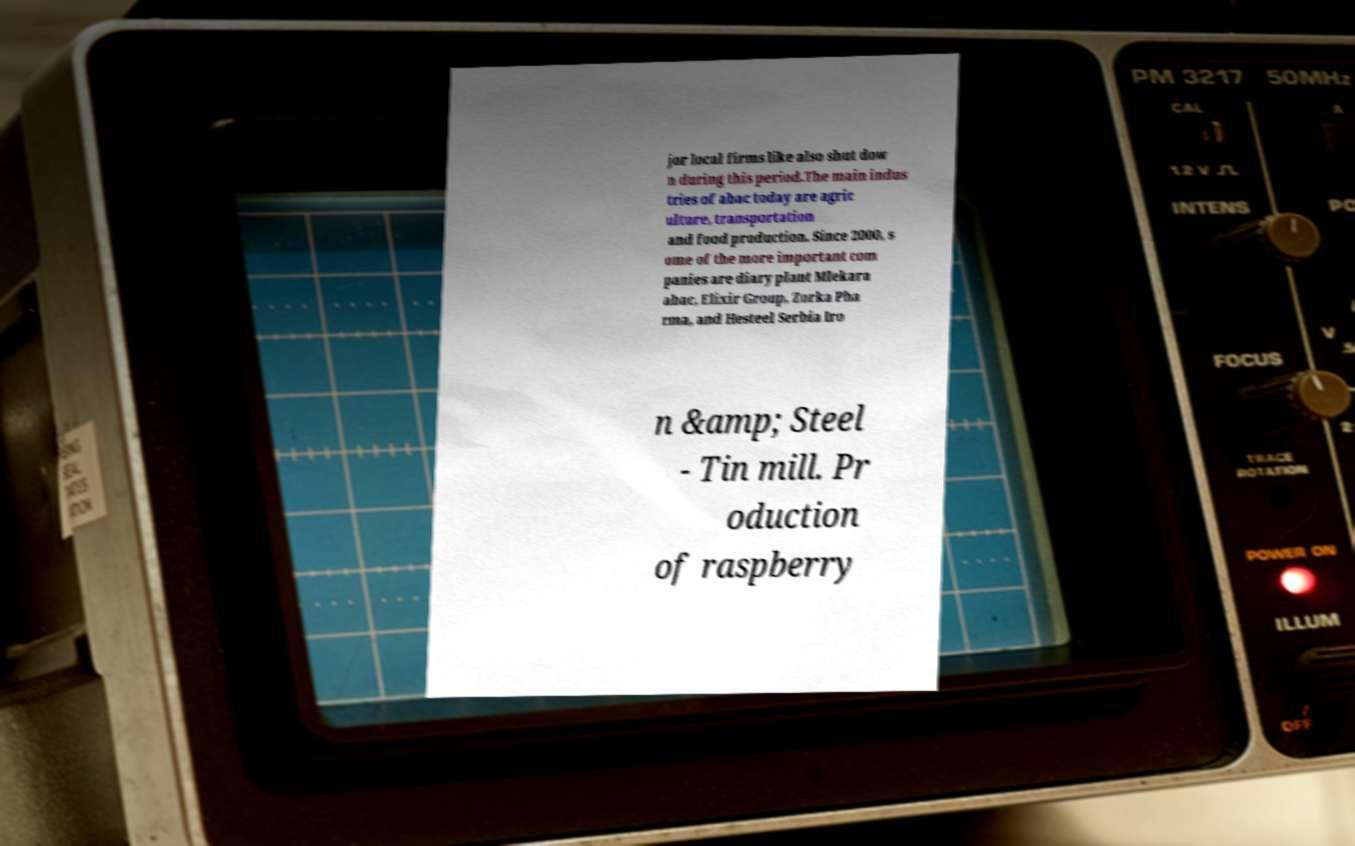I need the written content from this picture converted into text. Can you do that? jor local firms like also shut dow n during this period.The main indus tries of abac today are agric ulture, transportation and food production. Since 2000, s ome of the more important com panies are diary plant Mlekara abac, Elixir Group, Zorka Pha rma, and Hesteel Serbia Iro n &amp; Steel - Tin mill. Pr oduction of raspberry 